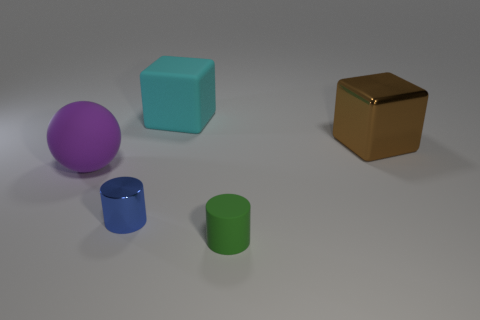Add 1 large blue matte blocks. How many objects exist? 6 Subtract all cylinders. How many objects are left? 3 Add 5 big cyan rubber things. How many big cyan rubber things are left? 6 Add 5 brown shiny cubes. How many brown shiny cubes exist? 6 Subtract 0 green blocks. How many objects are left? 5 Subtract all purple cubes. Subtract all cyan matte objects. How many objects are left? 4 